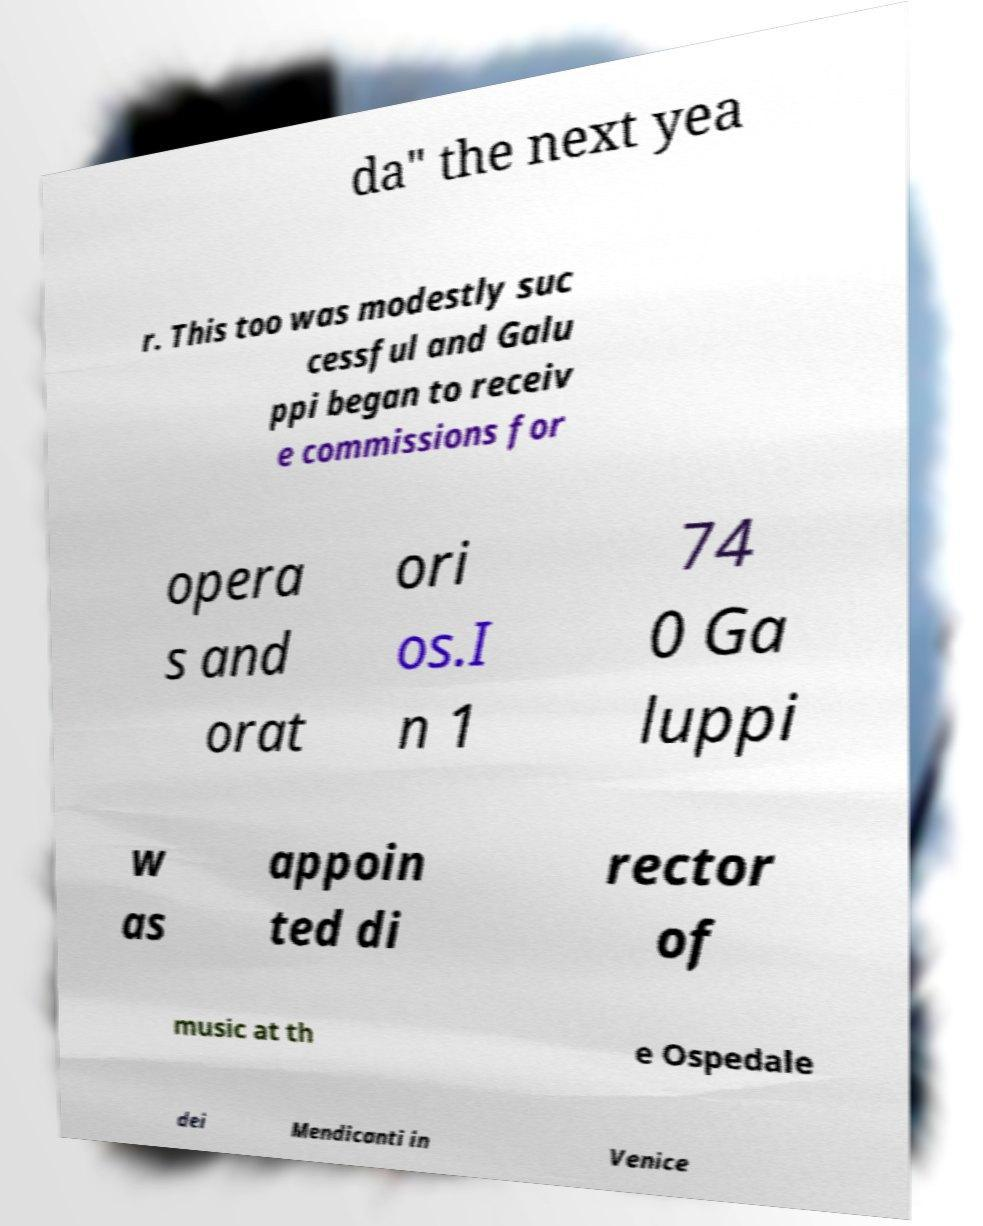There's text embedded in this image that I need extracted. Can you transcribe it verbatim? da" the next yea r. This too was modestly suc cessful and Galu ppi began to receiv e commissions for opera s and orat ori os.I n 1 74 0 Ga luppi w as appoin ted di rector of music at th e Ospedale dei Mendicanti in Venice 